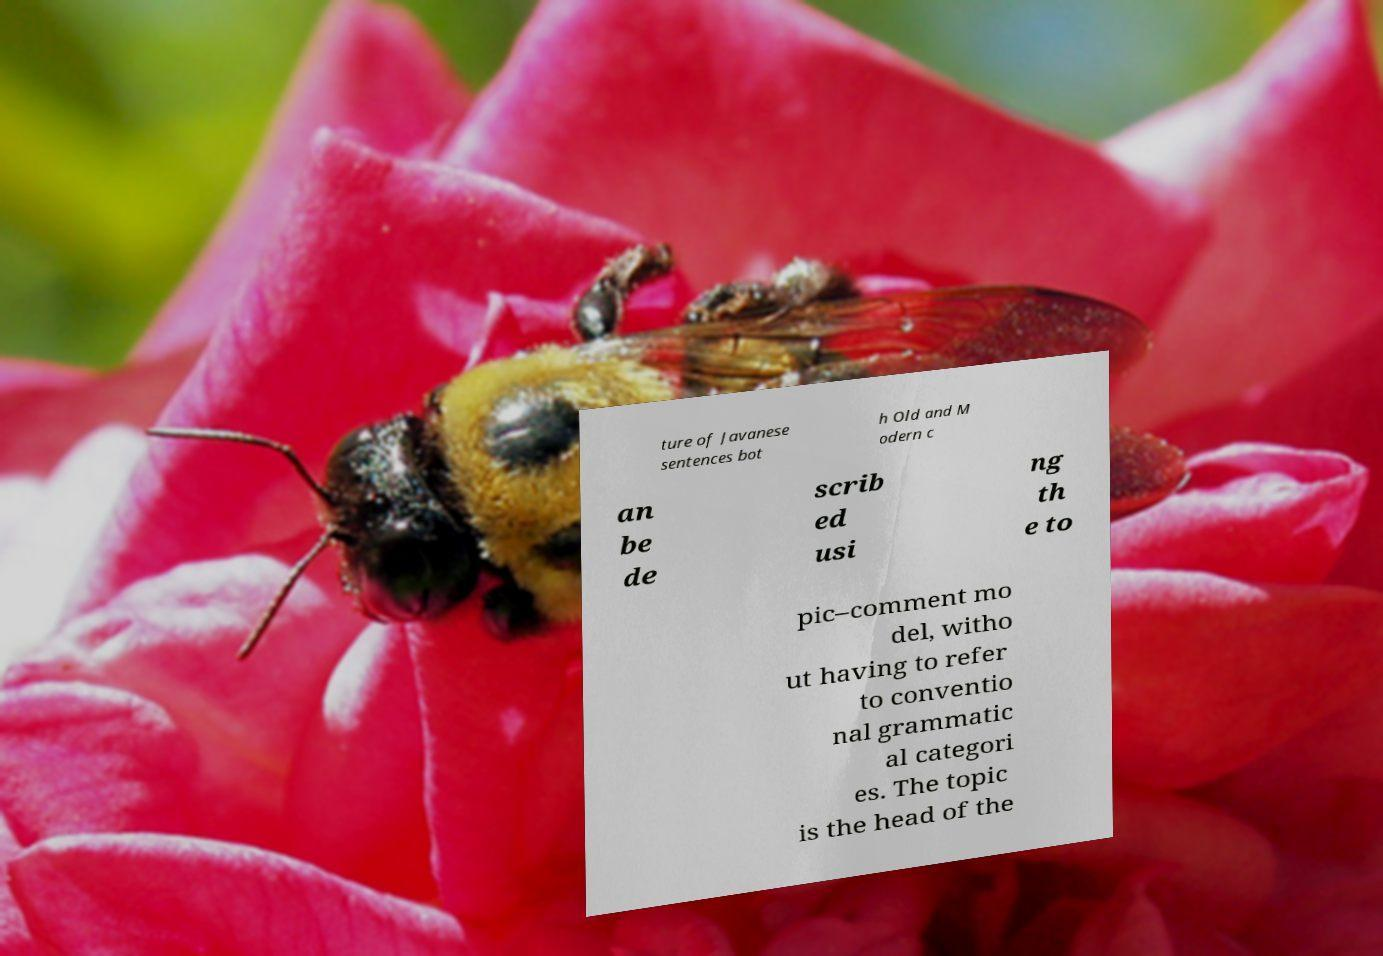I need the written content from this picture converted into text. Can you do that? ture of Javanese sentences bot h Old and M odern c an be de scrib ed usi ng th e to pic–comment mo del, witho ut having to refer to conventio nal grammatic al categori es. The topic is the head of the 